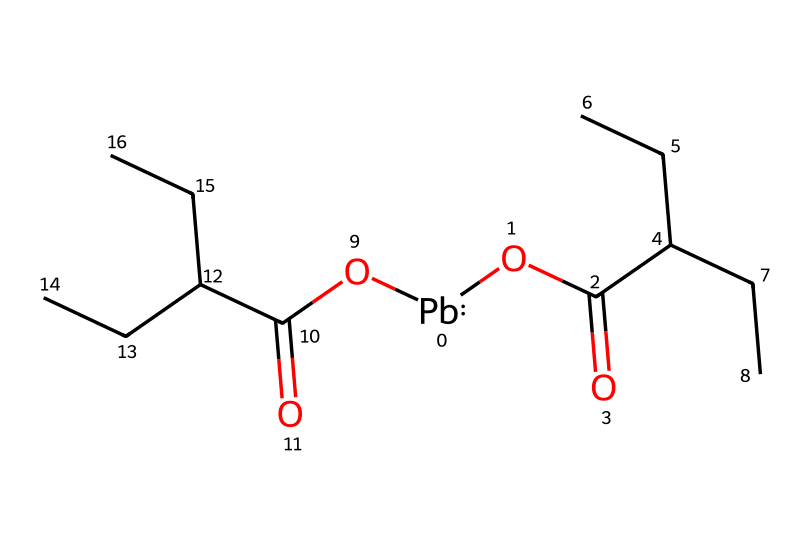How many lead atoms are present in this compound? By analyzing the SMILES representation, the notation "[Pb]" indicates there is one lead atom in the compound.
Answer: one What is the primary functional group in this chemical structure? The presence of "OC(=O)" indicates that the primary functional group is an ester, which is characterized by a carbonyl (C=O) adjacent to an ether (C-O) group.
Answer: ester How many carbon atoms are in the entire molecule? Counting the "C" from the esters and within the side chains, there are a total of 12 carbon atoms in the structure.
Answer: twelve What type of chemical is lead represented as in the SMILES string? The "[Pb]" notation shows that lead is treated as a lead ion, specifically a divalent lead ion in this context.
Answer: divalent lead ion Does this compound contain any hydroxyl groups? There are no "OH" or related representations in the SMILES string, indicating that there are no hydroxyl groups present in the structure.
Answer: no Is this compound likely to be soluble in organic solvents? Given the presence of ester linkages and alkyl chains, the compound's structure suggests it has hydrophobic properties, making it more soluble in organic solvents.
Answer: yes What potential environmental concerns are associated with lead compounds in paint? Lead compounds are associated with toxicity and environmental pollution, as lead is a heavy metal that can cause serious health issues if ingested or inhaled.
Answer: toxicity 